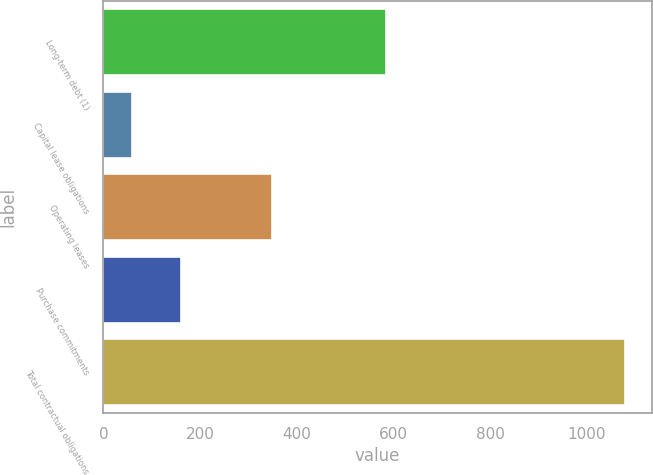Convert chart to OTSL. <chart><loc_0><loc_0><loc_500><loc_500><bar_chart><fcel>Long-term debt (1)<fcel>Capital lease obligations<fcel>Operating leases<fcel>Purchase commitments<fcel>Total contractual obligations<nl><fcel>585<fcel>59<fcel>349<fcel>161.1<fcel>1080<nl></chart> 